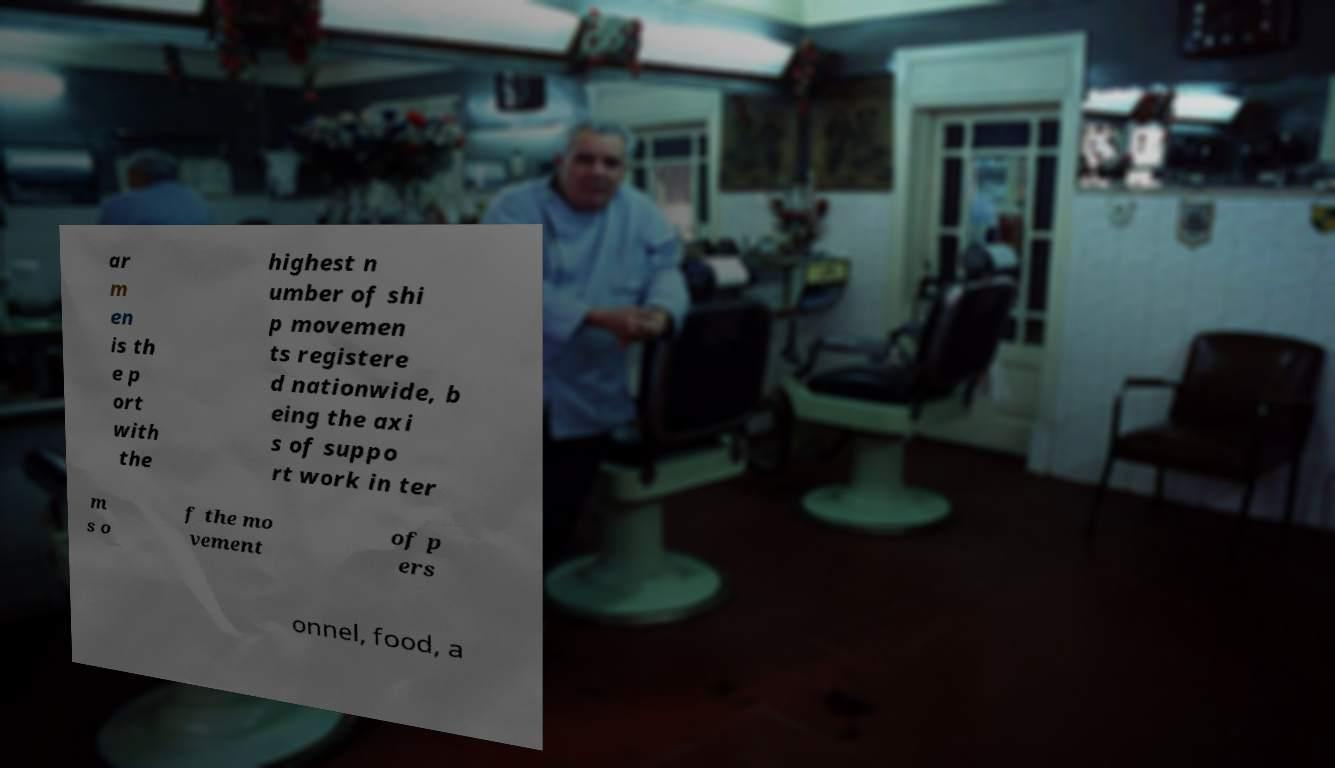There's text embedded in this image that I need extracted. Can you transcribe it verbatim? ar m en is th e p ort with the highest n umber of shi p movemen ts registere d nationwide, b eing the axi s of suppo rt work in ter m s o f the mo vement of p ers onnel, food, a 